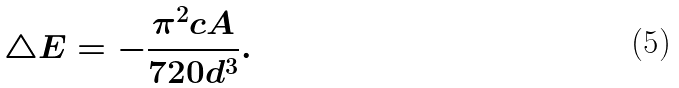<formula> <loc_0><loc_0><loc_500><loc_500>\bigtriangleup E = - { \frac { \pi ^ { 2 } { } c A } { 7 2 0 d ^ { 3 } } } .</formula> 